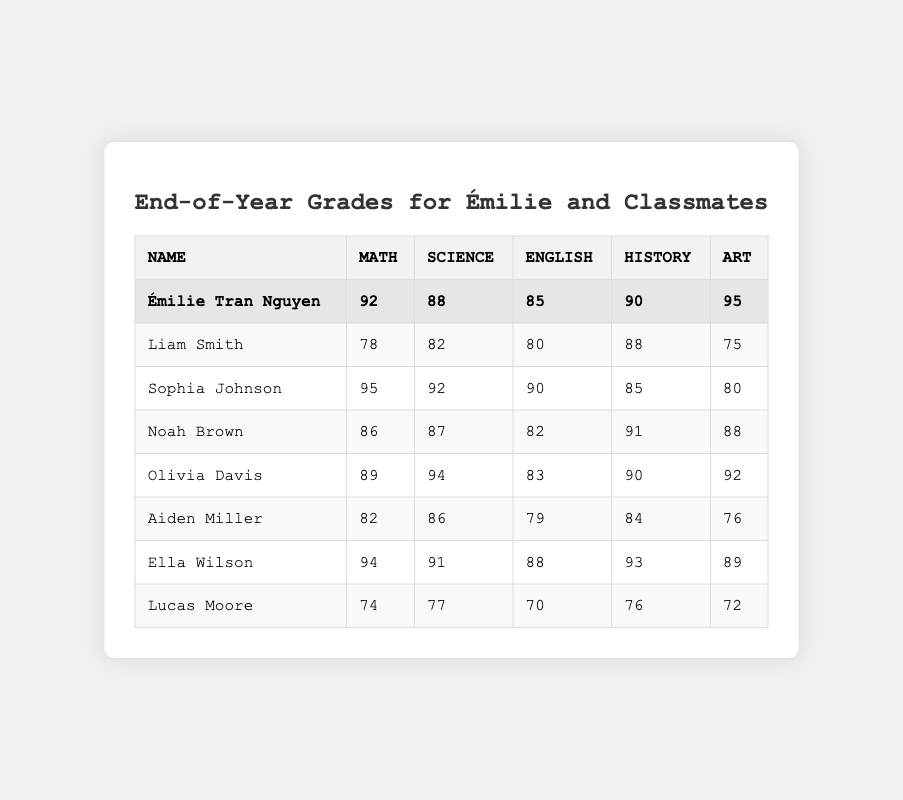What's Émilie's highest grade? Émilie's grades are 92 in Math, 88 in Science, 85 in English, 90 in History, and 95 in Art. The highest grade is 95 in Art.
Answer: 95 Which subject did Lucas score the lowest in? Lucas's grades are 74 in Math, 77 in Science, 70 in English, 76 in History, and 72 in Art. The lowest score is 70 in English.
Answer: 70 What is the average score for Sophia Johnson? To find Sophia's average, we add her scores (95 + 92 + 90 + 85 + 80) = 432 and divide by 5. 432 / 5 = 86.4.
Answer: 86.4 Did Aiden achieve more than 80 in Math? Aiden's Math score is 82. Since 82 is greater than 80, the answer is yes.
Answer: Yes Who has the highest grade in Science? The Science grades are 88 for Émilie, 82 for Liam, 92 for Sophia, 87 for Noah, 94 for Olivia, 86 for Aiden, 91 for Ella, and 77 for Lucas. The highest grade is 94 for Olivia.
Answer: Olivia Davis What is the difference between Émilie’s and Noah’s History grades? Émilie scored 90 in History while Noah scored 91. The difference is 91 - 90 = 1.
Answer: 1 How many students scored above 90 in Art? The Art grades are 95 for Émilie, 80 for Sophia, 88 for Noah, 92 for Olivia, 76 for Aiden, 89 for Ella, and 72 for Lucas. Émilie, Olivia, and Ella scored above 90, totaling 3 students.
Answer: 3 What's the sum of Liam's scores? Liam's scores are 78 in Math, 82 in Science, 80 in English, 88 in History, and 75 in Art. The sum is 78 + 82 + 80 + 88 + 75 = 403.
Answer: 403 Who has the second highest score in Math? The Math scores are 92 for Émilie, 78 for Liam, 95 for Sophia, 86 for Noah, 89 for Olivia, 82 for Aiden, 94 for Ella, and 74 for Lucas. The highest scores are 95 (Sophia) and then 94 (Ella), so Ella has the second highest.
Answer: Ella Wilson Which student has the highest overall average? We calculate averages for all students and find: Émilie: 90, Liam: 80.6, Sophia: 86.4, Noah: 86.8, Olivia: 89.6, Aiden: 81, Ella: 89, Lucas: 73. All averages compare, and Émilie's is the highest at 90.
Answer: Émilie Tran Nguyen 